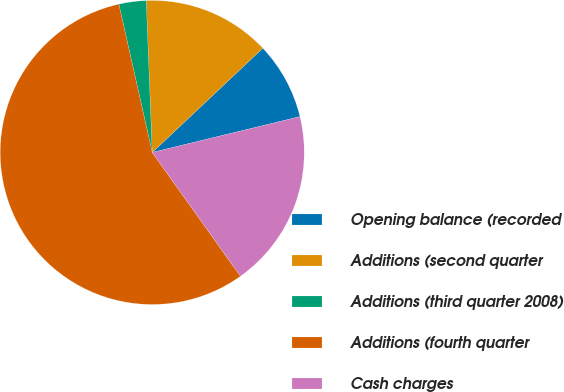Convert chart. <chart><loc_0><loc_0><loc_500><loc_500><pie_chart><fcel>Opening balance (recorded<fcel>Additions (second quarter<fcel>Additions (third quarter 2008)<fcel>Additions (fourth quarter<fcel>Cash charges<nl><fcel>8.25%<fcel>13.59%<fcel>2.9%<fcel>56.33%<fcel>18.93%<nl></chart> 